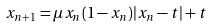<formula> <loc_0><loc_0><loc_500><loc_500>x _ { n + 1 } = \mu x _ { n } ( 1 - x _ { n } ) | x _ { n } - t | + t</formula> 